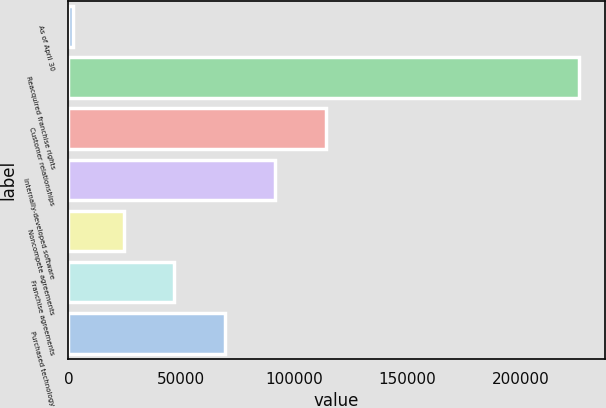<chart> <loc_0><loc_0><loc_500><loc_500><bar_chart><fcel>As of April 30<fcel>Reacquired franchise rights<fcel>Customer relationships<fcel>Internally-developed software<fcel>Noncompete agreements<fcel>Franchise agreements<fcel>Purchased technology<nl><fcel>2018<fcel>225923<fcel>113970<fcel>91580<fcel>24408.5<fcel>46799<fcel>69189.5<nl></chart> 